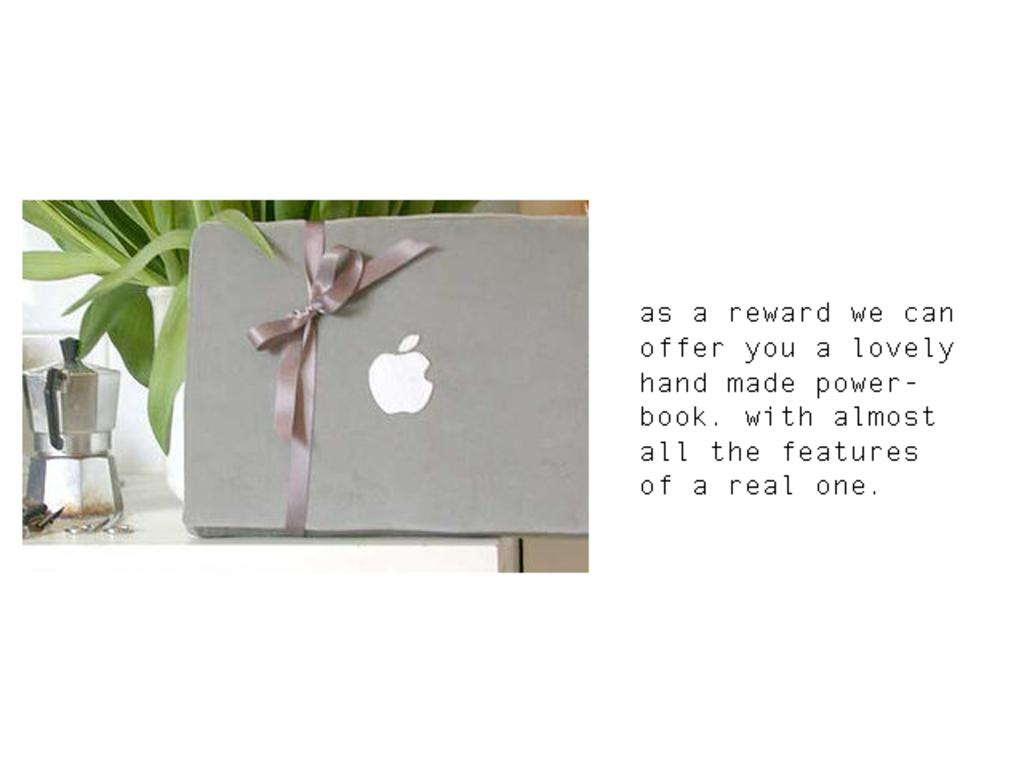<image>
Offer a succinct explanation of the picture presented. Next to a french press coffee maker is a grey notebook with an apple symbol on it, tied in a bow, and text offering it as a reward. 